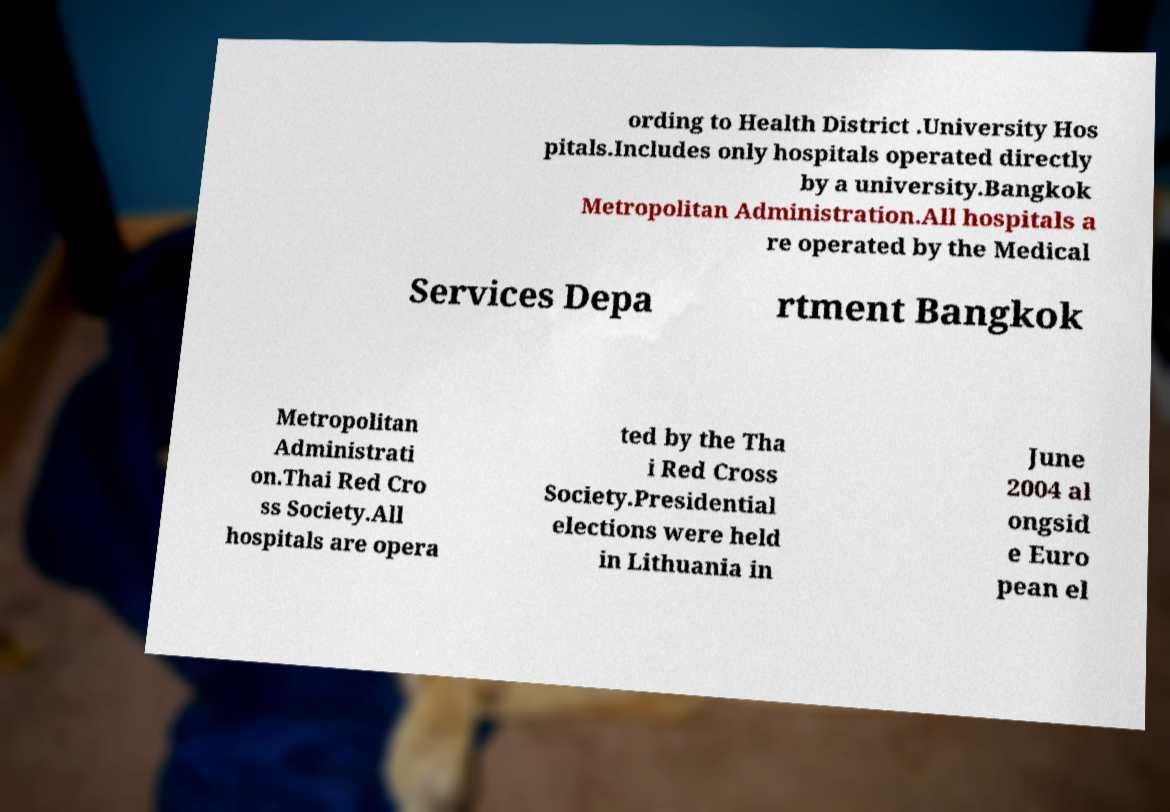Can you read and provide the text displayed in the image?This photo seems to have some interesting text. Can you extract and type it out for me? ording to Health District .University Hos pitals.Includes only hospitals operated directly by a university.Bangkok Metropolitan Administration.All hospitals a re operated by the Medical Services Depa rtment Bangkok Metropolitan Administrati on.Thai Red Cro ss Society.All hospitals are opera ted by the Tha i Red Cross Society.Presidential elections were held in Lithuania in June 2004 al ongsid e Euro pean el 